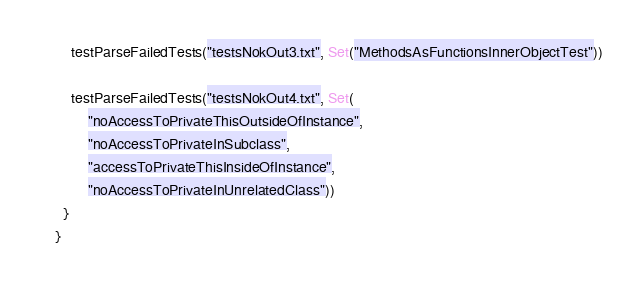Convert code to text. <code><loc_0><loc_0><loc_500><loc_500><_Scala_>    testParseFailedTests("testsNokOut3.txt", Set("MethodsAsFunctionsInnerObjectTest"))

    testParseFailedTests("testsNokOut4.txt", Set(
        "noAccessToPrivateThisOutsideOfInstance",
        "noAccessToPrivateInSubclass",
        "accessToPrivateThisInsideOfInstance",
        "noAccessToPrivateInUnrelatedClass"))
  }
}
</code> 